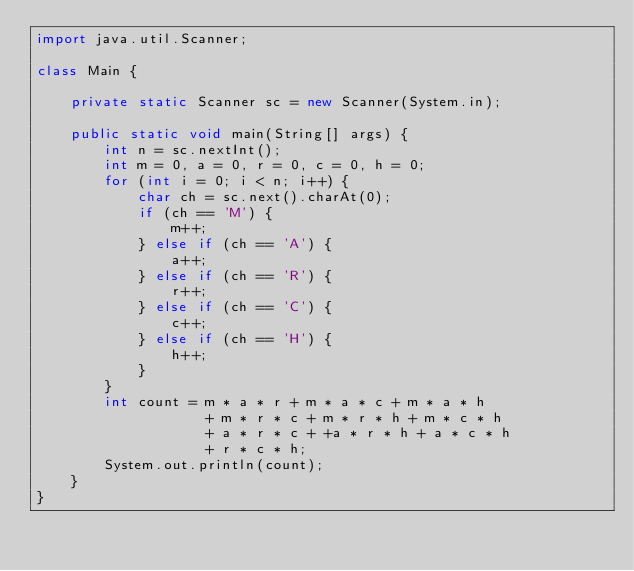Convert code to text. <code><loc_0><loc_0><loc_500><loc_500><_Java_>import java.util.Scanner;

class Main {

    private static Scanner sc = new Scanner(System.in);

    public static void main(String[] args) {
        int n = sc.nextInt();
        int m = 0, a = 0, r = 0, c = 0, h = 0;
        for (int i = 0; i < n; i++) {
            char ch = sc.next().charAt(0);
            if (ch == 'M') {
                m++;
            } else if (ch == 'A') {
                a++;
            } else if (ch == 'R') {
                r++;
            } else if (ch == 'C') {
                c++;
            } else if (ch == 'H') {
                h++;
            }
        }
        int count = m * a * r + m * a * c + m * a * h
                    + m * r * c + m * r * h + m * c * h
                    + a * r * c + +a * r * h + a * c * h
                    + r * c * h;
        System.out.println(count);
    }
}
</code> 